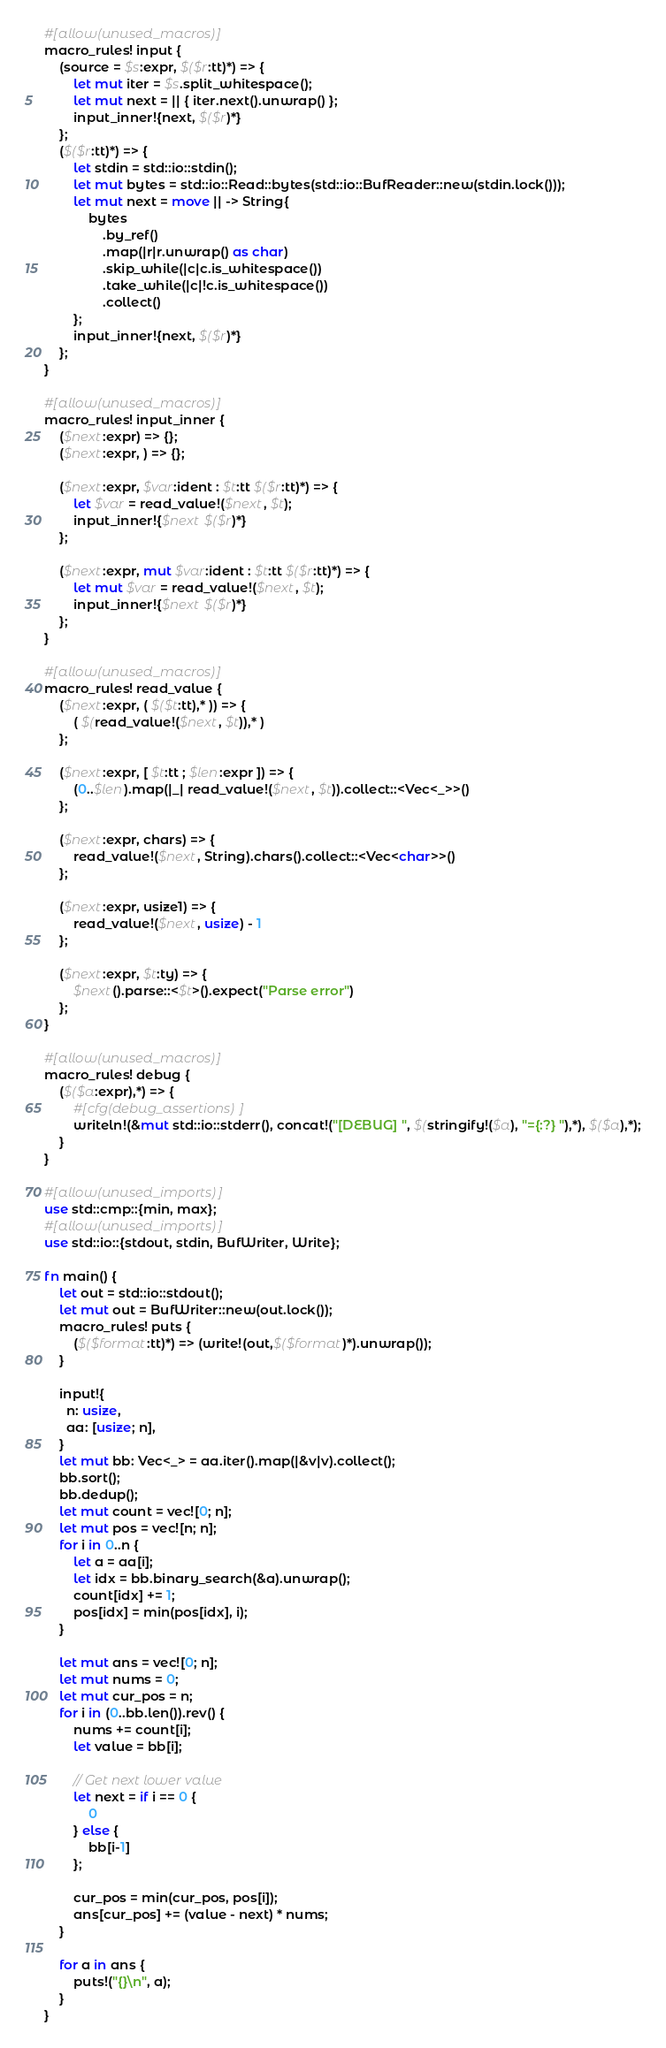Convert code to text. <code><loc_0><loc_0><loc_500><loc_500><_Rust_>#[allow(unused_macros)]
macro_rules! input {
    (source = $s:expr, $($r:tt)*) => {
        let mut iter = $s.split_whitespace();
        let mut next = || { iter.next().unwrap() };
        input_inner!{next, $($r)*}
    };
    ($($r:tt)*) => {
        let stdin = std::io::stdin();
        let mut bytes = std::io::Read::bytes(std::io::BufReader::new(stdin.lock()));
        let mut next = move || -> String{
            bytes
                .by_ref()
                .map(|r|r.unwrap() as char)
                .skip_while(|c|c.is_whitespace())
                .take_while(|c|!c.is_whitespace())
                .collect()
        };
        input_inner!{next, $($r)*}
    };
}

#[allow(unused_macros)]
macro_rules! input_inner {
    ($next:expr) => {};
    ($next:expr, ) => {};

    ($next:expr, $var:ident : $t:tt $($r:tt)*) => {
        let $var = read_value!($next, $t);
        input_inner!{$next $($r)*}
    };

    ($next:expr, mut $var:ident : $t:tt $($r:tt)*) => {
        let mut $var = read_value!($next, $t);
        input_inner!{$next $($r)*}
    };
}

#[allow(unused_macros)]
macro_rules! read_value {
    ($next:expr, ( $($t:tt),* )) => {
        ( $(read_value!($next, $t)),* )
    };

    ($next:expr, [ $t:tt ; $len:expr ]) => {
        (0..$len).map(|_| read_value!($next, $t)).collect::<Vec<_>>()
    };

    ($next:expr, chars) => {
        read_value!($next, String).chars().collect::<Vec<char>>()
    };

    ($next:expr, usize1) => {
        read_value!($next, usize) - 1
    };

    ($next:expr, $t:ty) => {
        $next().parse::<$t>().expect("Parse error")
    };
}

#[allow(unused_macros)]
macro_rules! debug {
    ($($a:expr),*) => {
        #[cfg(debug_assertions)]
        writeln!(&mut std::io::stderr(), concat!("[DEBUG] ", $(stringify!($a), "={:?} "),*), $($a),*);
    }
}

#[allow(unused_imports)]
use std::cmp::{min, max};
#[allow(unused_imports)]
use std::io::{stdout, stdin, BufWriter, Write};

fn main() {
    let out = std::io::stdout();
    let mut out = BufWriter::new(out.lock());
    macro_rules! puts {
        ($($format:tt)*) => (write!(out,$($format)*).unwrap());
    }

    input!{
      n: usize,
      aa: [usize; n],
    }
    let mut bb: Vec<_> = aa.iter().map(|&v|v).collect();
    bb.sort();
    bb.dedup();
    let mut count = vec![0; n];
    let mut pos = vec![n; n];
    for i in 0..n {
        let a = aa[i];
        let idx = bb.binary_search(&a).unwrap();
        count[idx] += 1;
        pos[idx] = min(pos[idx], i);
    }

    let mut ans = vec![0; n];
    let mut nums = 0;
    let mut cur_pos = n;
    for i in (0..bb.len()).rev() {
        nums += count[i];
        let value = bb[i];

        // Get next lower value
        let next = if i == 0 {
            0
        } else {
            bb[i-1]
        };

        cur_pos = min(cur_pos, pos[i]);
        ans[cur_pos] += (value - next) * nums;
    }

    for a in ans {
        puts!("{}\n", a);
    }
}
</code> 